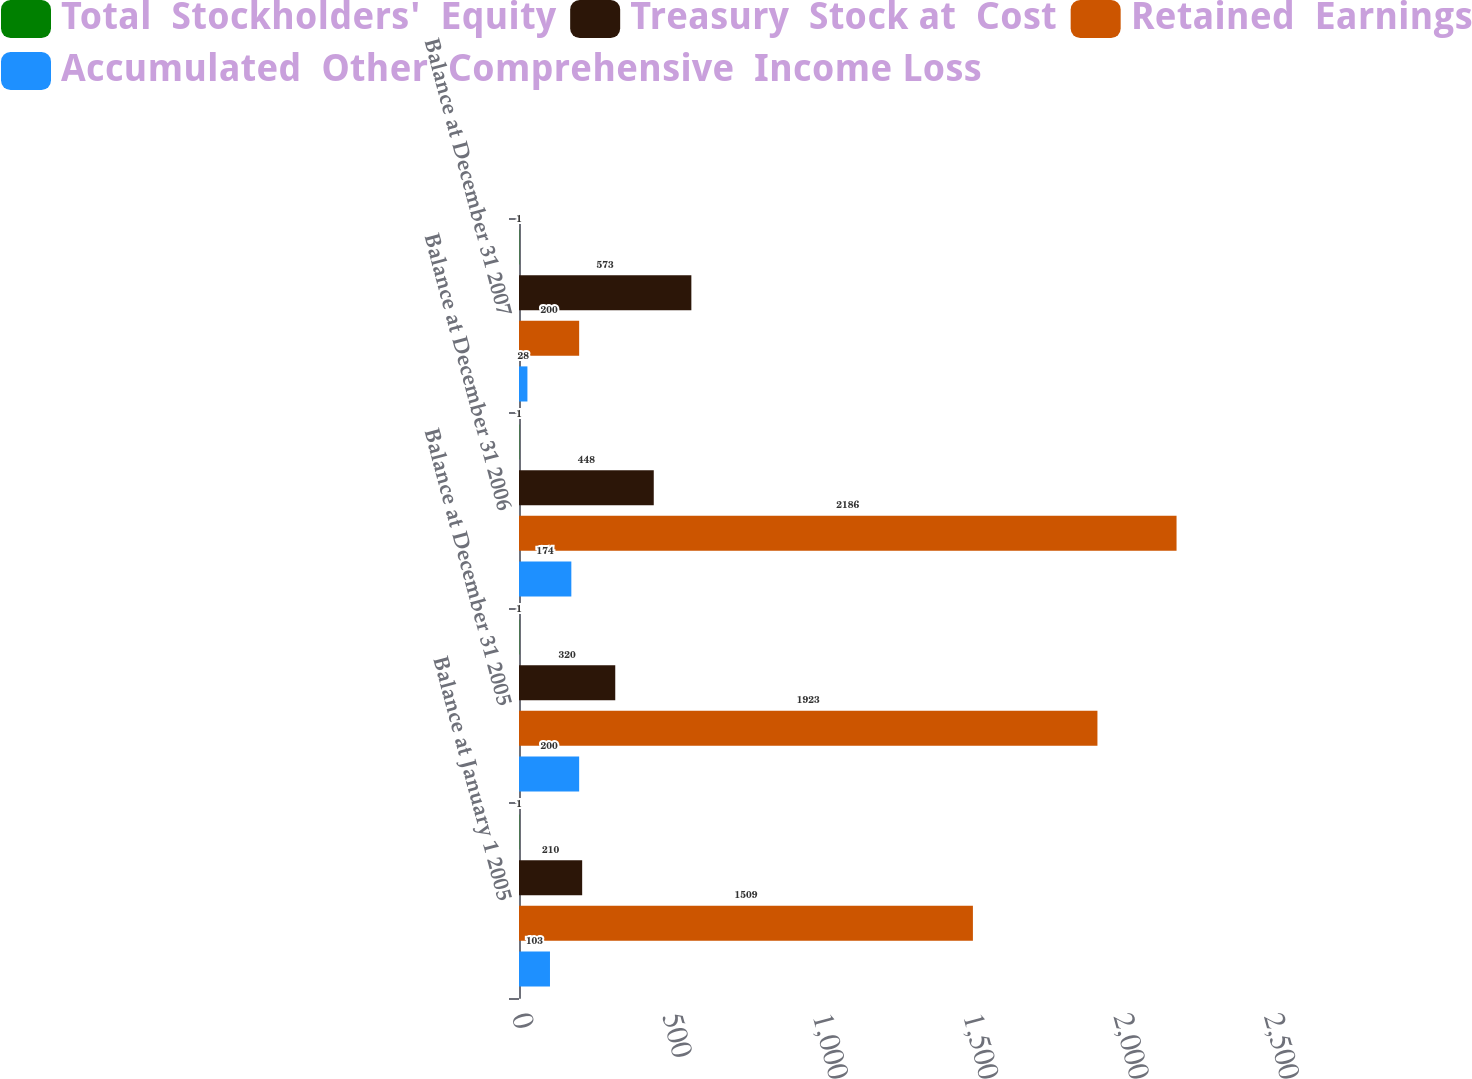Convert chart. <chart><loc_0><loc_0><loc_500><loc_500><stacked_bar_chart><ecel><fcel>Balance at January 1 2005<fcel>Balance at December 31 2005<fcel>Balance at December 31 2006<fcel>Balance at December 31 2007<nl><fcel>Total  Stockholders'  Equity<fcel>1<fcel>1<fcel>1<fcel>1<nl><fcel>Treasury  Stock at  Cost<fcel>210<fcel>320<fcel>448<fcel>573<nl><fcel>Retained  Earnings<fcel>1509<fcel>1923<fcel>2186<fcel>200<nl><fcel>Accumulated  Other  Comprehensive  Income Loss<fcel>103<fcel>200<fcel>174<fcel>28<nl></chart> 